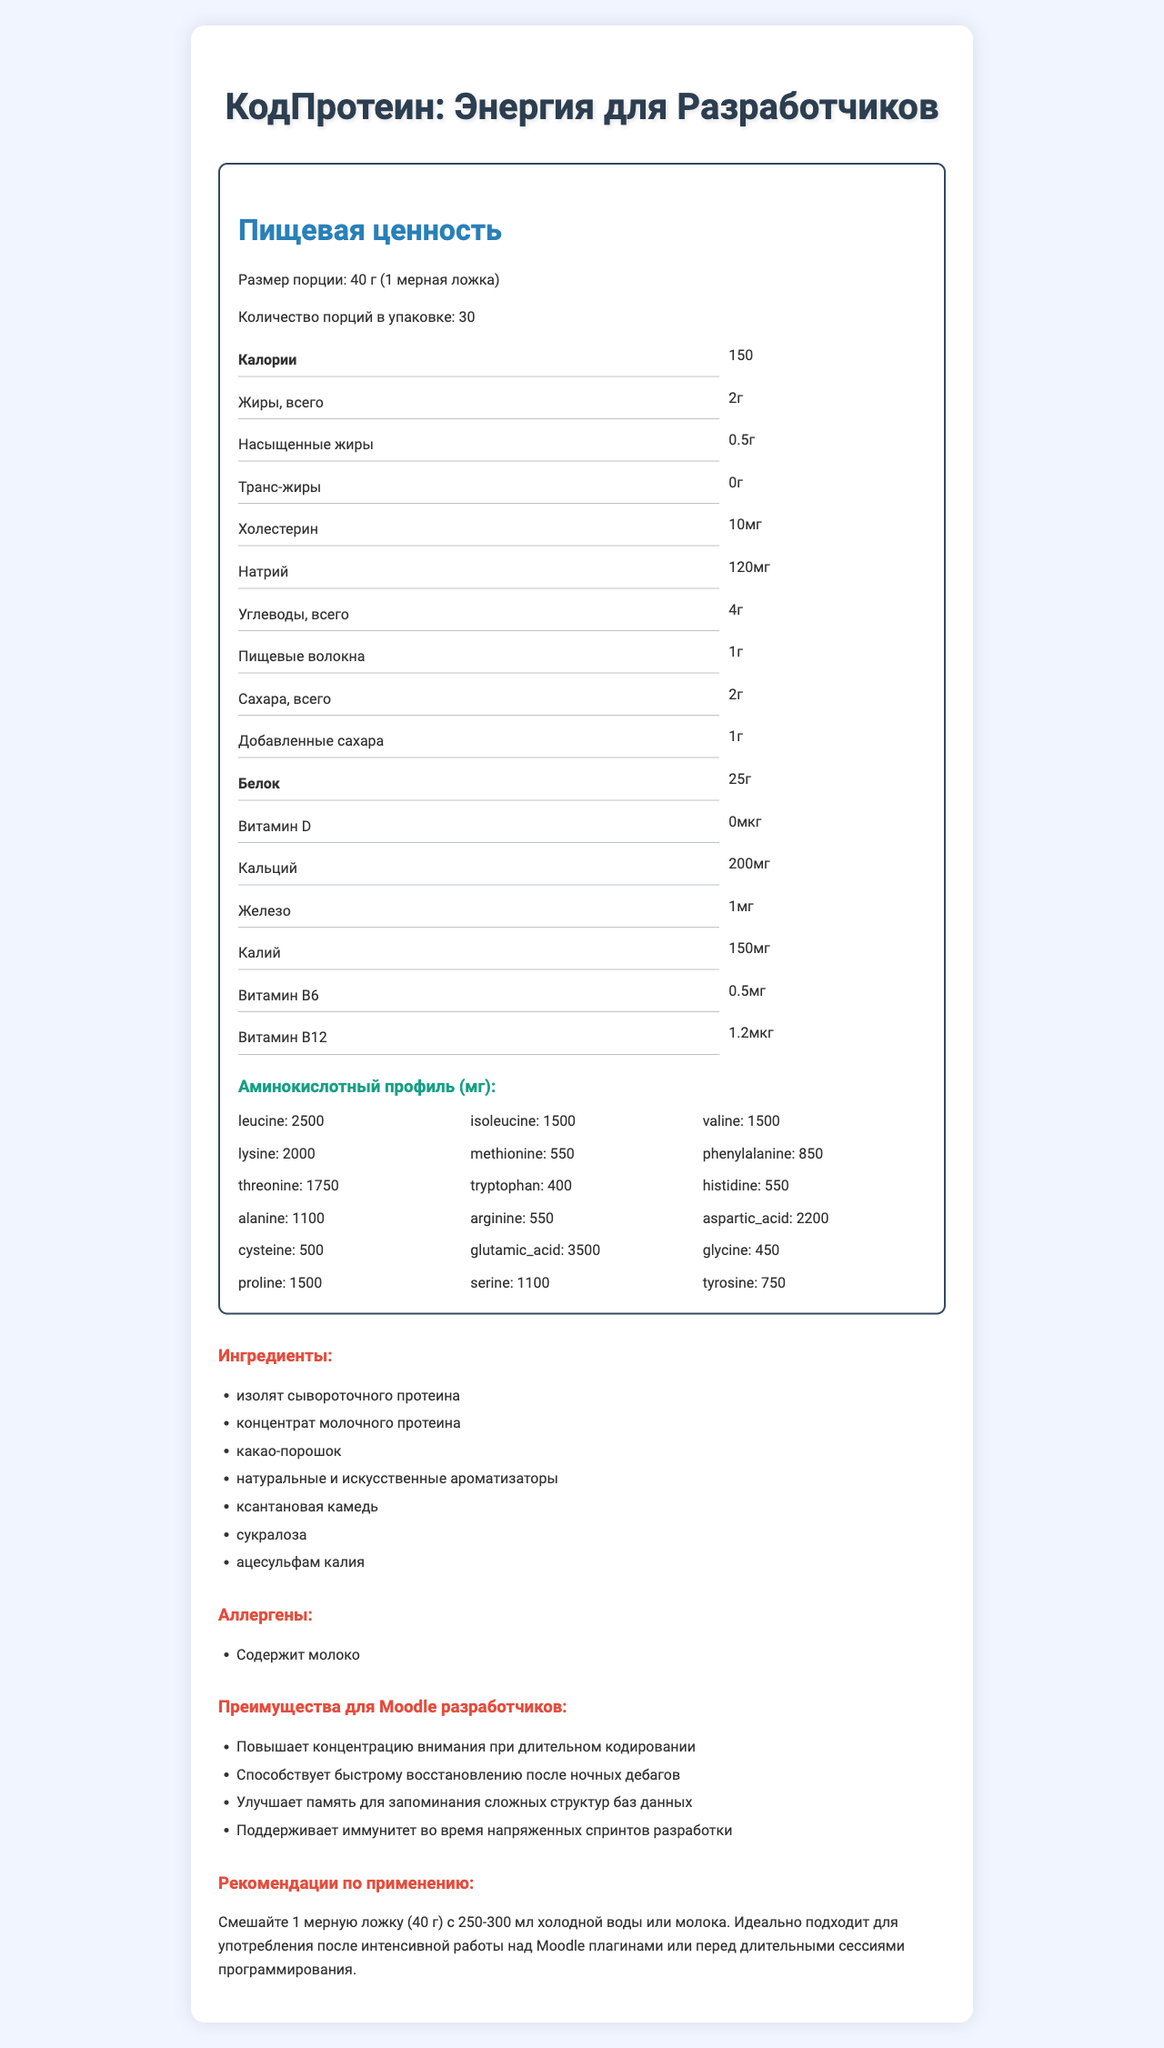what is the serving size of КодПротеин: Энергия для Разработчиков? The serving size is listed at the top section under "Размер порции".
Answer: 40 г (1 мерная ложка) how many calories are in one serving? The label shows that one serving contains 150 calories, found under "Калории".
Answer: 150 what is the total fat content per serving? The total fat content per serving is displayed as 2г.
Answer: 2г which vitamin has the highest amount per serving? Витамин B12 is listed as having 1.2мкг, the highest among the vitamins shown.
Answer: Витамин B12 what are the benefits of КодПротеин for Moodle developers? The benefits for Moodle developers are detailed in the "Преимущества для Moodle разработчиков" section with four specific points.
Answer: Повышает концентрацию внимания при длительном кодировании, Способствует быстрому восстановлению после ночных дебагов, Улучшает память для запоминания сложных структур баз данных, Поддерживает иммунитет во время напряженных спринтов разработки how much cholesterol is in one serving? The nutrition label specifies 10мг of cholesterol per serving.
Answer: 10мг what is the recommended usage for КодПротеин? The recommended usage is detailed in the "Рекомендации по применению" section.
Answer: Смешайте 1 мерную ложку (40 г) с 250-300 мл холодной воды или молока. Идеально подходит для употребления после интенсивной работы над Moodle плагинами или перед длительными сессиями программирования. which of the following is NOT an ingredient in КодПротеин: Энергия для Разработчиков? A. изолят сывороточного протеина B. какао-порошок C. аспартам The ingredients list does not include аспартам.
Answer: C how much leucine is in the amino acid profile per serving? The amino acid profile lists leucine as 2500мг per serving.
Answer: 2500мг does КодПротеин: Энергия для Разработчиков contain any allergens? The allergens section indicates that the product contains milk.
Answer: Yes how many grams of dietary fiber are in one serving? The label shows 1г of dietary fiber per serving.
Answer: 1г what are the total sugars per serving? The label indicates there are 2г of total sugars per serving.
Answer: 2г how much calcium is in one serving? A. 100мг B. 200мг C. 250мг D. 150мг The nutrition facts section lists calcium as 200мг per serving.
Answer: B which amino acid has the lowest amount per serving? A. glycine B. tryptophan C. lysine D. tyrosine The amino acid profile shows glycine as 450мг, which is the lowest listed amount.
Answer: glycine is there any trans fat in one serving? The label indicates there are 0г of trans fat per serving.
Answer: No summarize the nutritional benefits and target audience of КодПротеин: Энергия для Разработчиков. The summary combines detailed nutritional information with the benefits and target audience specific to Moodle developers, highlighting its suitability and recommended usage.
Answer: The product provides a balanced nutritional profile with 150 calories, 25 grams of protein, and essential vitamins and minerals. It has an extensive amino acid profile, making it suitable for enhancing focus, recovery, memory, and immunity for Moodle developers. The product contains milk allergens and has a recommended usage for optimal results. what brand manufactures КодПротеин: Энергия для Разработчиков? The document does not provide any information about the manufacturer or brand.
Answer: Cannot be determined 